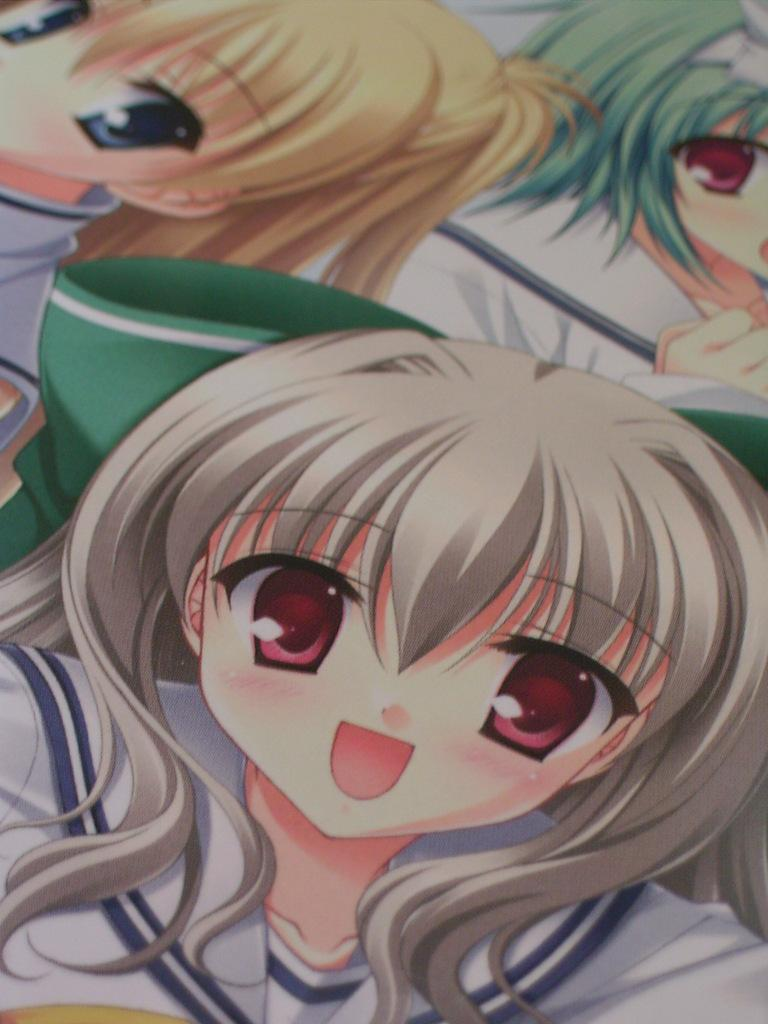What type of content is depicted in the image? There are cartoons in the image. What is the distance between the cartoon characters and the yard in the image? There is no yard present in the image, as it only contains cartoons. 